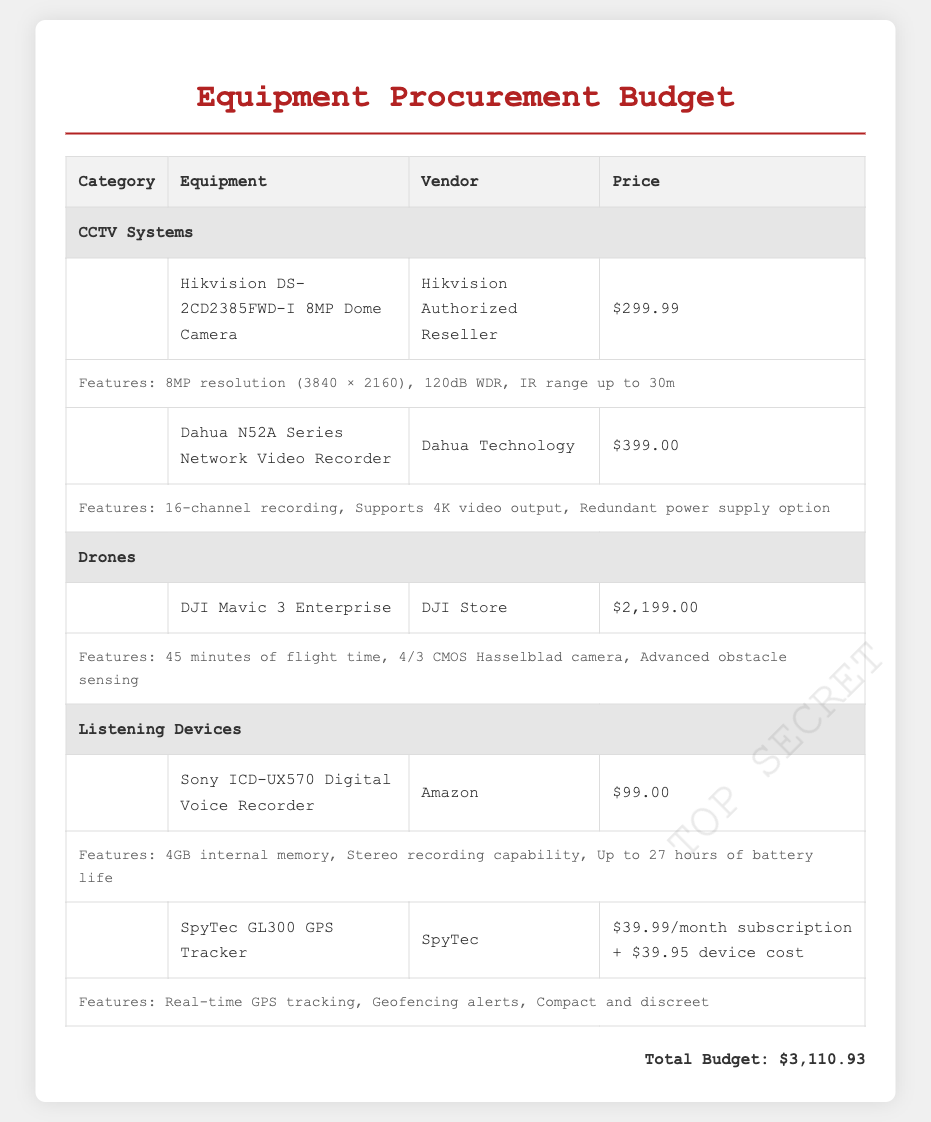What is the total budget? The total budget is stated at the bottom of the table, summing up all the equipment costs.
Answer: $3,110.93 Which vendor supplies the DJI Mavic 3 Enterprise? The vendor for the DJI Mavic 3 Enterprise is mentioned in the specific row detailing this drone.
Answer: DJI Store How much does the Sony ICD-UX570 Digital Voice Recorder cost? The price for the Sony ICD-UX570 is provided next to the equipment name in the document.
Answer: $99.00 What is a feature of the Hikvision DS-2CD2385FWD-I camera? Features of the Hikvision camera are outlined in a separate entry right below the product details.
Answer: 8MP resolution How many channels does the Dahua N52A Series Network Video Recorder support? The details about the number of channels supported by the Dahua device are found in the features section accompanying its entry.
Answer: 16-channel What is the monthly subscription cost for the SpyTec GL300 GPS Tracker? The monthly subscription price is specified alongside the device cost in the document.
Answer: $39.99/month Which equipment has advanced obstacle sensing as a feature? This detail is found under the features of the DJI Mavic 3 Enterprise drone.
Answer: DJI Mavic 3 Enterprise What is the price for the Dahua N52A Series Network Video Recorder? The price is directly listed in the table against the equipment description.
Answer: $399.00 How long is the flight time for the DJI Mavic 3 Enterprise? This information is provided in the features section detailing the drone's capabilities.
Answer: 45 minutes 